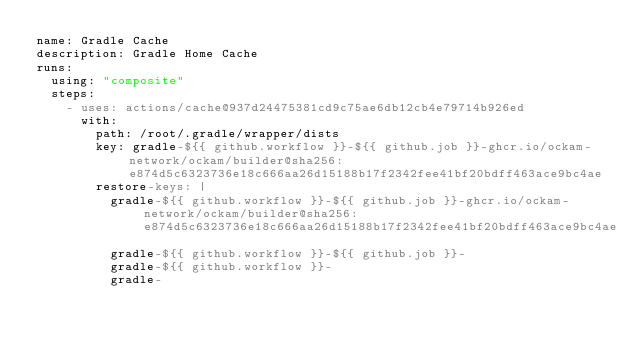<code> <loc_0><loc_0><loc_500><loc_500><_YAML_>name: Gradle Cache
description: Gradle Home Cache
runs:
  using: "composite"
  steps:
    - uses: actions/cache@937d24475381cd9c75ae6db12cb4e79714b926ed
      with:
        path: /root/.gradle/wrapper/dists
        key: gradle-${{ github.workflow }}-${{ github.job }}-ghcr.io/ockam-network/ockam/builder@sha256:e874d5c6323736e18c666aa26d15188b17f2342fee41bf20bdff463ace9bc4ae
        restore-keys: |
          gradle-${{ github.workflow }}-${{ github.job }}-ghcr.io/ockam-network/ockam/builder@sha256:e874d5c6323736e18c666aa26d15188b17f2342fee41bf20bdff463ace9bc4ae
          gradle-${{ github.workflow }}-${{ github.job }}-
          gradle-${{ github.workflow }}-
          gradle-
</code> 